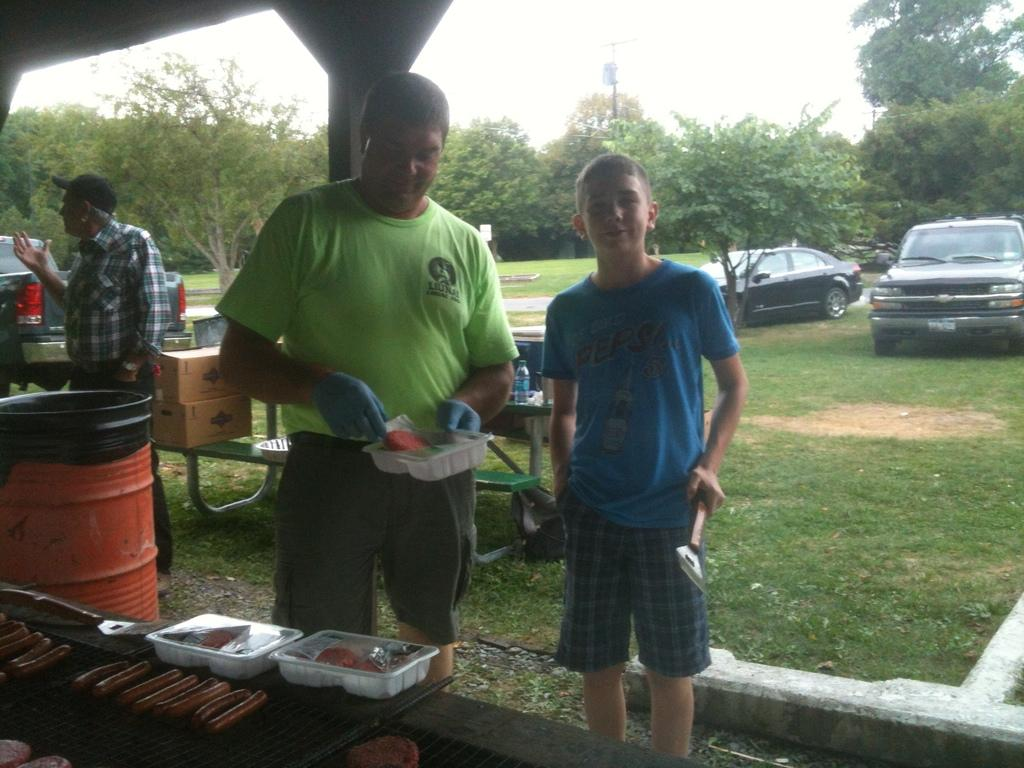How many people are in the image? There are three men in the image. What are the men doing in the image? The men are standing in the image. What can be seen behind the men? There are cars behind the men. What type of natural elements are visible in the image? There are trees visible in the image. What are the men holding in their hands? The men are holding something in their hands. What type of caption is written on the image? There is no caption written on the image; it is a photograph without any text. What type of lead can be seen in the image? There is no lead present in the image. 